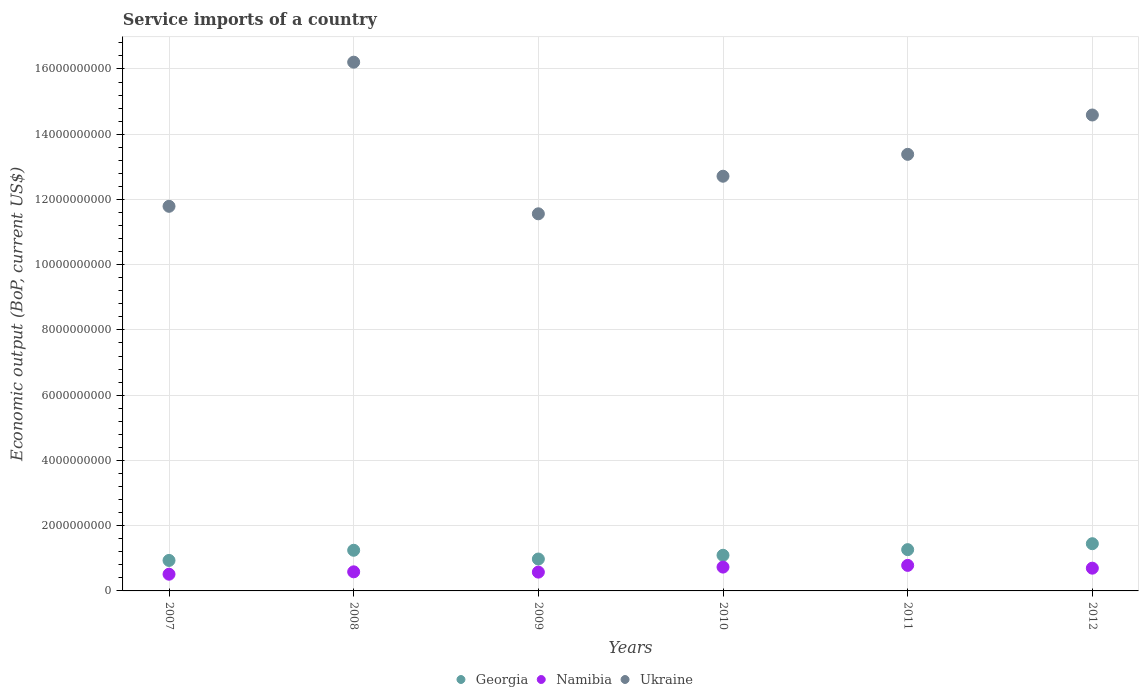How many different coloured dotlines are there?
Provide a short and direct response. 3. What is the service imports in Namibia in 2009?
Give a very brief answer. 5.76e+08. Across all years, what is the maximum service imports in Georgia?
Provide a short and direct response. 1.45e+09. Across all years, what is the minimum service imports in Namibia?
Provide a short and direct response. 5.12e+08. In which year was the service imports in Georgia minimum?
Offer a terse response. 2007. What is the total service imports in Namibia in the graph?
Your answer should be very brief. 3.88e+09. What is the difference between the service imports in Georgia in 2009 and that in 2012?
Offer a very short reply. -4.70e+08. What is the difference between the service imports in Georgia in 2009 and the service imports in Ukraine in 2012?
Provide a short and direct response. -1.36e+1. What is the average service imports in Georgia per year?
Ensure brevity in your answer.  1.16e+09. In the year 2012, what is the difference between the service imports in Ukraine and service imports in Namibia?
Ensure brevity in your answer.  1.39e+1. In how many years, is the service imports in Namibia greater than 7600000000 US$?
Provide a short and direct response. 0. What is the ratio of the service imports in Ukraine in 2007 to that in 2012?
Offer a very short reply. 0.81. What is the difference between the highest and the second highest service imports in Ukraine?
Your answer should be compact. 1.62e+09. What is the difference between the highest and the lowest service imports in Namibia?
Keep it short and to the point. 2.71e+08. How many dotlines are there?
Give a very brief answer. 3. How many years are there in the graph?
Your answer should be very brief. 6. What is the difference between two consecutive major ticks on the Y-axis?
Keep it short and to the point. 2.00e+09. Are the values on the major ticks of Y-axis written in scientific E-notation?
Offer a terse response. No. Does the graph contain any zero values?
Keep it short and to the point. No. What is the title of the graph?
Provide a short and direct response. Service imports of a country. What is the label or title of the Y-axis?
Offer a terse response. Economic output (BoP, current US$). What is the Economic output (BoP, current US$) of Georgia in 2007?
Your response must be concise. 9.35e+08. What is the Economic output (BoP, current US$) in Namibia in 2007?
Your answer should be very brief. 5.12e+08. What is the Economic output (BoP, current US$) of Ukraine in 2007?
Offer a very short reply. 1.18e+1. What is the Economic output (BoP, current US$) of Georgia in 2008?
Provide a succinct answer. 1.25e+09. What is the Economic output (BoP, current US$) in Namibia in 2008?
Your answer should be compact. 5.85e+08. What is the Economic output (BoP, current US$) in Ukraine in 2008?
Offer a terse response. 1.62e+1. What is the Economic output (BoP, current US$) of Georgia in 2009?
Give a very brief answer. 9.78e+08. What is the Economic output (BoP, current US$) of Namibia in 2009?
Ensure brevity in your answer.  5.76e+08. What is the Economic output (BoP, current US$) in Ukraine in 2009?
Give a very brief answer. 1.16e+1. What is the Economic output (BoP, current US$) in Georgia in 2010?
Offer a terse response. 1.09e+09. What is the Economic output (BoP, current US$) in Namibia in 2010?
Your answer should be very brief. 7.31e+08. What is the Economic output (BoP, current US$) of Ukraine in 2010?
Offer a very short reply. 1.27e+1. What is the Economic output (BoP, current US$) of Georgia in 2011?
Make the answer very short. 1.27e+09. What is the Economic output (BoP, current US$) of Namibia in 2011?
Offer a very short reply. 7.83e+08. What is the Economic output (BoP, current US$) of Ukraine in 2011?
Make the answer very short. 1.34e+1. What is the Economic output (BoP, current US$) in Georgia in 2012?
Your answer should be compact. 1.45e+09. What is the Economic output (BoP, current US$) in Namibia in 2012?
Offer a terse response. 6.97e+08. What is the Economic output (BoP, current US$) in Ukraine in 2012?
Your response must be concise. 1.46e+1. Across all years, what is the maximum Economic output (BoP, current US$) of Georgia?
Provide a short and direct response. 1.45e+09. Across all years, what is the maximum Economic output (BoP, current US$) in Namibia?
Ensure brevity in your answer.  7.83e+08. Across all years, what is the maximum Economic output (BoP, current US$) of Ukraine?
Your response must be concise. 1.62e+1. Across all years, what is the minimum Economic output (BoP, current US$) of Georgia?
Provide a succinct answer. 9.35e+08. Across all years, what is the minimum Economic output (BoP, current US$) in Namibia?
Your response must be concise. 5.12e+08. Across all years, what is the minimum Economic output (BoP, current US$) of Ukraine?
Make the answer very short. 1.16e+1. What is the total Economic output (BoP, current US$) of Georgia in the graph?
Keep it short and to the point. 6.96e+09. What is the total Economic output (BoP, current US$) of Namibia in the graph?
Provide a succinct answer. 3.88e+09. What is the total Economic output (BoP, current US$) of Ukraine in the graph?
Your answer should be very brief. 8.02e+1. What is the difference between the Economic output (BoP, current US$) in Georgia in 2007 and that in 2008?
Keep it short and to the point. -3.11e+08. What is the difference between the Economic output (BoP, current US$) in Namibia in 2007 and that in 2008?
Your answer should be very brief. -7.30e+07. What is the difference between the Economic output (BoP, current US$) of Ukraine in 2007 and that in 2008?
Provide a short and direct response. -4.42e+09. What is the difference between the Economic output (BoP, current US$) in Georgia in 2007 and that in 2009?
Your response must be concise. -4.29e+07. What is the difference between the Economic output (BoP, current US$) of Namibia in 2007 and that in 2009?
Make the answer very short. -6.41e+07. What is the difference between the Economic output (BoP, current US$) in Ukraine in 2007 and that in 2009?
Give a very brief answer. 2.30e+08. What is the difference between the Economic output (BoP, current US$) in Georgia in 2007 and that in 2010?
Your answer should be compact. -1.58e+08. What is the difference between the Economic output (BoP, current US$) of Namibia in 2007 and that in 2010?
Ensure brevity in your answer.  -2.18e+08. What is the difference between the Economic output (BoP, current US$) of Ukraine in 2007 and that in 2010?
Provide a short and direct response. -9.22e+08. What is the difference between the Economic output (BoP, current US$) of Georgia in 2007 and that in 2011?
Keep it short and to the point. -3.31e+08. What is the difference between the Economic output (BoP, current US$) in Namibia in 2007 and that in 2011?
Your answer should be very brief. -2.71e+08. What is the difference between the Economic output (BoP, current US$) in Ukraine in 2007 and that in 2011?
Your answer should be compact. -1.59e+09. What is the difference between the Economic output (BoP, current US$) of Georgia in 2007 and that in 2012?
Keep it short and to the point. -5.13e+08. What is the difference between the Economic output (BoP, current US$) of Namibia in 2007 and that in 2012?
Provide a short and direct response. -1.85e+08. What is the difference between the Economic output (BoP, current US$) in Ukraine in 2007 and that in 2012?
Ensure brevity in your answer.  -2.80e+09. What is the difference between the Economic output (BoP, current US$) of Georgia in 2008 and that in 2009?
Provide a succinct answer. 2.69e+08. What is the difference between the Economic output (BoP, current US$) in Namibia in 2008 and that in 2009?
Provide a succinct answer. 8.86e+06. What is the difference between the Economic output (BoP, current US$) in Ukraine in 2008 and that in 2009?
Give a very brief answer. 4.65e+09. What is the difference between the Economic output (BoP, current US$) of Georgia in 2008 and that in 2010?
Your answer should be very brief. 1.54e+08. What is the difference between the Economic output (BoP, current US$) of Namibia in 2008 and that in 2010?
Provide a succinct answer. -1.45e+08. What is the difference between the Economic output (BoP, current US$) of Ukraine in 2008 and that in 2010?
Ensure brevity in your answer.  3.50e+09. What is the difference between the Economic output (BoP, current US$) of Georgia in 2008 and that in 2011?
Your response must be concise. -1.90e+07. What is the difference between the Economic output (BoP, current US$) in Namibia in 2008 and that in 2011?
Ensure brevity in your answer.  -1.98e+08. What is the difference between the Economic output (BoP, current US$) of Ukraine in 2008 and that in 2011?
Your response must be concise. 2.82e+09. What is the difference between the Economic output (BoP, current US$) in Georgia in 2008 and that in 2012?
Offer a terse response. -2.01e+08. What is the difference between the Economic output (BoP, current US$) in Namibia in 2008 and that in 2012?
Give a very brief answer. -1.12e+08. What is the difference between the Economic output (BoP, current US$) of Ukraine in 2008 and that in 2012?
Offer a very short reply. 1.62e+09. What is the difference between the Economic output (BoP, current US$) in Georgia in 2009 and that in 2010?
Give a very brief answer. -1.15e+08. What is the difference between the Economic output (BoP, current US$) of Namibia in 2009 and that in 2010?
Provide a short and direct response. -1.54e+08. What is the difference between the Economic output (BoP, current US$) of Ukraine in 2009 and that in 2010?
Give a very brief answer. -1.15e+09. What is the difference between the Economic output (BoP, current US$) in Georgia in 2009 and that in 2011?
Keep it short and to the point. -2.88e+08. What is the difference between the Economic output (BoP, current US$) in Namibia in 2009 and that in 2011?
Give a very brief answer. -2.06e+08. What is the difference between the Economic output (BoP, current US$) in Ukraine in 2009 and that in 2011?
Offer a terse response. -1.82e+09. What is the difference between the Economic output (BoP, current US$) of Georgia in 2009 and that in 2012?
Keep it short and to the point. -4.70e+08. What is the difference between the Economic output (BoP, current US$) in Namibia in 2009 and that in 2012?
Offer a very short reply. -1.21e+08. What is the difference between the Economic output (BoP, current US$) in Ukraine in 2009 and that in 2012?
Offer a very short reply. -3.03e+09. What is the difference between the Economic output (BoP, current US$) of Georgia in 2010 and that in 2011?
Ensure brevity in your answer.  -1.73e+08. What is the difference between the Economic output (BoP, current US$) of Namibia in 2010 and that in 2011?
Keep it short and to the point. -5.22e+07. What is the difference between the Economic output (BoP, current US$) in Ukraine in 2010 and that in 2011?
Provide a succinct answer. -6.71e+08. What is the difference between the Economic output (BoP, current US$) in Georgia in 2010 and that in 2012?
Make the answer very short. -3.55e+08. What is the difference between the Economic output (BoP, current US$) of Namibia in 2010 and that in 2012?
Your answer should be compact. 3.34e+07. What is the difference between the Economic output (BoP, current US$) of Ukraine in 2010 and that in 2012?
Provide a short and direct response. -1.88e+09. What is the difference between the Economic output (BoP, current US$) in Georgia in 2011 and that in 2012?
Give a very brief answer. -1.82e+08. What is the difference between the Economic output (BoP, current US$) in Namibia in 2011 and that in 2012?
Your answer should be very brief. 8.56e+07. What is the difference between the Economic output (BoP, current US$) of Ukraine in 2011 and that in 2012?
Your answer should be very brief. -1.21e+09. What is the difference between the Economic output (BoP, current US$) in Georgia in 2007 and the Economic output (BoP, current US$) in Namibia in 2008?
Offer a very short reply. 3.49e+08. What is the difference between the Economic output (BoP, current US$) of Georgia in 2007 and the Economic output (BoP, current US$) of Ukraine in 2008?
Make the answer very short. -1.53e+1. What is the difference between the Economic output (BoP, current US$) in Namibia in 2007 and the Economic output (BoP, current US$) in Ukraine in 2008?
Provide a short and direct response. -1.57e+1. What is the difference between the Economic output (BoP, current US$) of Georgia in 2007 and the Economic output (BoP, current US$) of Namibia in 2009?
Your answer should be compact. 3.58e+08. What is the difference between the Economic output (BoP, current US$) in Georgia in 2007 and the Economic output (BoP, current US$) in Ukraine in 2009?
Provide a succinct answer. -1.06e+1. What is the difference between the Economic output (BoP, current US$) in Namibia in 2007 and the Economic output (BoP, current US$) in Ukraine in 2009?
Keep it short and to the point. -1.10e+1. What is the difference between the Economic output (BoP, current US$) in Georgia in 2007 and the Economic output (BoP, current US$) in Namibia in 2010?
Ensure brevity in your answer.  2.04e+08. What is the difference between the Economic output (BoP, current US$) in Georgia in 2007 and the Economic output (BoP, current US$) in Ukraine in 2010?
Give a very brief answer. -1.18e+1. What is the difference between the Economic output (BoP, current US$) of Namibia in 2007 and the Economic output (BoP, current US$) of Ukraine in 2010?
Your answer should be very brief. -1.22e+1. What is the difference between the Economic output (BoP, current US$) of Georgia in 2007 and the Economic output (BoP, current US$) of Namibia in 2011?
Your answer should be very brief. 1.52e+08. What is the difference between the Economic output (BoP, current US$) of Georgia in 2007 and the Economic output (BoP, current US$) of Ukraine in 2011?
Provide a succinct answer. -1.24e+1. What is the difference between the Economic output (BoP, current US$) in Namibia in 2007 and the Economic output (BoP, current US$) in Ukraine in 2011?
Provide a succinct answer. -1.29e+1. What is the difference between the Economic output (BoP, current US$) in Georgia in 2007 and the Economic output (BoP, current US$) in Namibia in 2012?
Provide a short and direct response. 2.37e+08. What is the difference between the Economic output (BoP, current US$) of Georgia in 2007 and the Economic output (BoP, current US$) of Ukraine in 2012?
Ensure brevity in your answer.  -1.37e+1. What is the difference between the Economic output (BoP, current US$) in Namibia in 2007 and the Economic output (BoP, current US$) in Ukraine in 2012?
Your response must be concise. -1.41e+1. What is the difference between the Economic output (BoP, current US$) of Georgia in 2008 and the Economic output (BoP, current US$) of Namibia in 2009?
Provide a succinct answer. 6.70e+08. What is the difference between the Economic output (BoP, current US$) in Georgia in 2008 and the Economic output (BoP, current US$) in Ukraine in 2009?
Offer a terse response. -1.03e+1. What is the difference between the Economic output (BoP, current US$) in Namibia in 2008 and the Economic output (BoP, current US$) in Ukraine in 2009?
Your answer should be very brief. -1.10e+1. What is the difference between the Economic output (BoP, current US$) of Georgia in 2008 and the Economic output (BoP, current US$) of Namibia in 2010?
Your answer should be very brief. 5.16e+08. What is the difference between the Economic output (BoP, current US$) of Georgia in 2008 and the Economic output (BoP, current US$) of Ukraine in 2010?
Your answer should be compact. -1.15e+1. What is the difference between the Economic output (BoP, current US$) of Namibia in 2008 and the Economic output (BoP, current US$) of Ukraine in 2010?
Ensure brevity in your answer.  -1.21e+1. What is the difference between the Economic output (BoP, current US$) of Georgia in 2008 and the Economic output (BoP, current US$) of Namibia in 2011?
Give a very brief answer. 4.63e+08. What is the difference between the Economic output (BoP, current US$) in Georgia in 2008 and the Economic output (BoP, current US$) in Ukraine in 2011?
Make the answer very short. -1.21e+1. What is the difference between the Economic output (BoP, current US$) in Namibia in 2008 and the Economic output (BoP, current US$) in Ukraine in 2011?
Provide a succinct answer. -1.28e+1. What is the difference between the Economic output (BoP, current US$) of Georgia in 2008 and the Economic output (BoP, current US$) of Namibia in 2012?
Your response must be concise. 5.49e+08. What is the difference between the Economic output (BoP, current US$) of Georgia in 2008 and the Economic output (BoP, current US$) of Ukraine in 2012?
Provide a short and direct response. -1.33e+1. What is the difference between the Economic output (BoP, current US$) in Namibia in 2008 and the Economic output (BoP, current US$) in Ukraine in 2012?
Offer a very short reply. -1.40e+1. What is the difference between the Economic output (BoP, current US$) in Georgia in 2009 and the Economic output (BoP, current US$) in Namibia in 2010?
Your response must be concise. 2.47e+08. What is the difference between the Economic output (BoP, current US$) of Georgia in 2009 and the Economic output (BoP, current US$) of Ukraine in 2010?
Keep it short and to the point. -1.17e+1. What is the difference between the Economic output (BoP, current US$) in Namibia in 2009 and the Economic output (BoP, current US$) in Ukraine in 2010?
Offer a terse response. -1.21e+1. What is the difference between the Economic output (BoP, current US$) of Georgia in 2009 and the Economic output (BoP, current US$) of Namibia in 2011?
Your answer should be very brief. 1.95e+08. What is the difference between the Economic output (BoP, current US$) of Georgia in 2009 and the Economic output (BoP, current US$) of Ukraine in 2011?
Give a very brief answer. -1.24e+1. What is the difference between the Economic output (BoP, current US$) of Namibia in 2009 and the Economic output (BoP, current US$) of Ukraine in 2011?
Ensure brevity in your answer.  -1.28e+1. What is the difference between the Economic output (BoP, current US$) in Georgia in 2009 and the Economic output (BoP, current US$) in Namibia in 2012?
Your answer should be compact. 2.80e+08. What is the difference between the Economic output (BoP, current US$) of Georgia in 2009 and the Economic output (BoP, current US$) of Ukraine in 2012?
Offer a terse response. -1.36e+1. What is the difference between the Economic output (BoP, current US$) of Namibia in 2009 and the Economic output (BoP, current US$) of Ukraine in 2012?
Offer a very short reply. -1.40e+1. What is the difference between the Economic output (BoP, current US$) of Georgia in 2010 and the Economic output (BoP, current US$) of Namibia in 2011?
Ensure brevity in your answer.  3.10e+08. What is the difference between the Economic output (BoP, current US$) in Georgia in 2010 and the Economic output (BoP, current US$) in Ukraine in 2011?
Offer a very short reply. -1.23e+1. What is the difference between the Economic output (BoP, current US$) in Namibia in 2010 and the Economic output (BoP, current US$) in Ukraine in 2011?
Keep it short and to the point. -1.27e+1. What is the difference between the Economic output (BoP, current US$) in Georgia in 2010 and the Economic output (BoP, current US$) in Namibia in 2012?
Give a very brief answer. 3.95e+08. What is the difference between the Economic output (BoP, current US$) of Georgia in 2010 and the Economic output (BoP, current US$) of Ukraine in 2012?
Make the answer very short. -1.35e+1. What is the difference between the Economic output (BoP, current US$) of Namibia in 2010 and the Economic output (BoP, current US$) of Ukraine in 2012?
Ensure brevity in your answer.  -1.39e+1. What is the difference between the Economic output (BoP, current US$) in Georgia in 2011 and the Economic output (BoP, current US$) in Namibia in 2012?
Your response must be concise. 5.68e+08. What is the difference between the Economic output (BoP, current US$) in Georgia in 2011 and the Economic output (BoP, current US$) in Ukraine in 2012?
Provide a short and direct response. -1.33e+1. What is the difference between the Economic output (BoP, current US$) of Namibia in 2011 and the Economic output (BoP, current US$) of Ukraine in 2012?
Offer a terse response. -1.38e+1. What is the average Economic output (BoP, current US$) in Georgia per year?
Keep it short and to the point. 1.16e+09. What is the average Economic output (BoP, current US$) in Namibia per year?
Your answer should be very brief. 6.47e+08. What is the average Economic output (BoP, current US$) of Ukraine per year?
Your answer should be compact. 1.34e+1. In the year 2007, what is the difference between the Economic output (BoP, current US$) of Georgia and Economic output (BoP, current US$) of Namibia?
Your answer should be very brief. 4.22e+08. In the year 2007, what is the difference between the Economic output (BoP, current US$) in Georgia and Economic output (BoP, current US$) in Ukraine?
Offer a very short reply. -1.09e+1. In the year 2007, what is the difference between the Economic output (BoP, current US$) of Namibia and Economic output (BoP, current US$) of Ukraine?
Offer a terse response. -1.13e+1. In the year 2008, what is the difference between the Economic output (BoP, current US$) of Georgia and Economic output (BoP, current US$) of Namibia?
Provide a succinct answer. 6.61e+08. In the year 2008, what is the difference between the Economic output (BoP, current US$) in Georgia and Economic output (BoP, current US$) in Ukraine?
Ensure brevity in your answer.  -1.50e+1. In the year 2008, what is the difference between the Economic output (BoP, current US$) of Namibia and Economic output (BoP, current US$) of Ukraine?
Your response must be concise. -1.56e+1. In the year 2009, what is the difference between the Economic output (BoP, current US$) of Georgia and Economic output (BoP, current US$) of Namibia?
Make the answer very short. 4.01e+08. In the year 2009, what is the difference between the Economic output (BoP, current US$) in Georgia and Economic output (BoP, current US$) in Ukraine?
Provide a short and direct response. -1.06e+1. In the year 2009, what is the difference between the Economic output (BoP, current US$) of Namibia and Economic output (BoP, current US$) of Ukraine?
Provide a short and direct response. -1.10e+1. In the year 2010, what is the difference between the Economic output (BoP, current US$) of Georgia and Economic output (BoP, current US$) of Namibia?
Your answer should be compact. 3.62e+08. In the year 2010, what is the difference between the Economic output (BoP, current US$) of Georgia and Economic output (BoP, current US$) of Ukraine?
Provide a succinct answer. -1.16e+1. In the year 2010, what is the difference between the Economic output (BoP, current US$) of Namibia and Economic output (BoP, current US$) of Ukraine?
Give a very brief answer. -1.20e+1. In the year 2011, what is the difference between the Economic output (BoP, current US$) in Georgia and Economic output (BoP, current US$) in Namibia?
Ensure brevity in your answer.  4.82e+08. In the year 2011, what is the difference between the Economic output (BoP, current US$) in Georgia and Economic output (BoP, current US$) in Ukraine?
Keep it short and to the point. -1.21e+1. In the year 2011, what is the difference between the Economic output (BoP, current US$) of Namibia and Economic output (BoP, current US$) of Ukraine?
Make the answer very short. -1.26e+1. In the year 2012, what is the difference between the Economic output (BoP, current US$) of Georgia and Economic output (BoP, current US$) of Namibia?
Make the answer very short. 7.50e+08. In the year 2012, what is the difference between the Economic output (BoP, current US$) in Georgia and Economic output (BoP, current US$) in Ukraine?
Keep it short and to the point. -1.31e+1. In the year 2012, what is the difference between the Economic output (BoP, current US$) in Namibia and Economic output (BoP, current US$) in Ukraine?
Offer a very short reply. -1.39e+1. What is the ratio of the Economic output (BoP, current US$) of Georgia in 2007 to that in 2008?
Provide a short and direct response. 0.75. What is the ratio of the Economic output (BoP, current US$) of Namibia in 2007 to that in 2008?
Provide a short and direct response. 0.88. What is the ratio of the Economic output (BoP, current US$) of Ukraine in 2007 to that in 2008?
Give a very brief answer. 0.73. What is the ratio of the Economic output (BoP, current US$) in Georgia in 2007 to that in 2009?
Your answer should be very brief. 0.96. What is the ratio of the Economic output (BoP, current US$) in Namibia in 2007 to that in 2009?
Make the answer very short. 0.89. What is the ratio of the Economic output (BoP, current US$) of Ukraine in 2007 to that in 2009?
Ensure brevity in your answer.  1.02. What is the ratio of the Economic output (BoP, current US$) in Georgia in 2007 to that in 2010?
Offer a terse response. 0.86. What is the ratio of the Economic output (BoP, current US$) of Namibia in 2007 to that in 2010?
Ensure brevity in your answer.  0.7. What is the ratio of the Economic output (BoP, current US$) in Ukraine in 2007 to that in 2010?
Ensure brevity in your answer.  0.93. What is the ratio of the Economic output (BoP, current US$) of Georgia in 2007 to that in 2011?
Provide a succinct answer. 0.74. What is the ratio of the Economic output (BoP, current US$) of Namibia in 2007 to that in 2011?
Keep it short and to the point. 0.65. What is the ratio of the Economic output (BoP, current US$) in Ukraine in 2007 to that in 2011?
Your response must be concise. 0.88. What is the ratio of the Economic output (BoP, current US$) in Georgia in 2007 to that in 2012?
Your answer should be compact. 0.65. What is the ratio of the Economic output (BoP, current US$) of Namibia in 2007 to that in 2012?
Your response must be concise. 0.73. What is the ratio of the Economic output (BoP, current US$) in Ukraine in 2007 to that in 2012?
Offer a very short reply. 0.81. What is the ratio of the Economic output (BoP, current US$) of Georgia in 2008 to that in 2009?
Keep it short and to the point. 1.27. What is the ratio of the Economic output (BoP, current US$) in Namibia in 2008 to that in 2009?
Your response must be concise. 1.02. What is the ratio of the Economic output (BoP, current US$) in Ukraine in 2008 to that in 2009?
Your answer should be very brief. 1.4. What is the ratio of the Economic output (BoP, current US$) in Georgia in 2008 to that in 2010?
Make the answer very short. 1.14. What is the ratio of the Economic output (BoP, current US$) in Namibia in 2008 to that in 2010?
Your response must be concise. 0.8. What is the ratio of the Economic output (BoP, current US$) in Ukraine in 2008 to that in 2010?
Your response must be concise. 1.27. What is the ratio of the Economic output (BoP, current US$) of Georgia in 2008 to that in 2011?
Give a very brief answer. 0.98. What is the ratio of the Economic output (BoP, current US$) of Namibia in 2008 to that in 2011?
Provide a short and direct response. 0.75. What is the ratio of the Economic output (BoP, current US$) of Ukraine in 2008 to that in 2011?
Offer a very short reply. 1.21. What is the ratio of the Economic output (BoP, current US$) of Georgia in 2008 to that in 2012?
Your answer should be very brief. 0.86. What is the ratio of the Economic output (BoP, current US$) of Namibia in 2008 to that in 2012?
Your answer should be very brief. 0.84. What is the ratio of the Economic output (BoP, current US$) of Ukraine in 2008 to that in 2012?
Your answer should be very brief. 1.11. What is the ratio of the Economic output (BoP, current US$) of Georgia in 2009 to that in 2010?
Make the answer very short. 0.89. What is the ratio of the Economic output (BoP, current US$) in Namibia in 2009 to that in 2010?
Your answer should be very brief. 0.79. What is the ratio of the Economic output (BoP, current US$) in Ukraine in 2009 to that in 2010?
Keep it short and to the point. 0.91. What is the ratio of the Economic output (BoP, current US$) of Georgia in 2009 to that in 2011?
Your answer should be very brief. 0.77. What is the ratio of the Economic output (BoP, current US$) in Namibia in 2009 to that in 2011?
Offer a very short reply. 0.74. What is the ratio of the Economic output (BoP, current US$) in Ukraine in 2009 to that in 2011?
Keep it short and to the point. 0.86. What is the ratio of the Economic output (BoP, current US$) in Georgia in 2009 to that in 2012?
Provide a short and direct response. 0.68. What is the ratio of the Economic output (BoP, current US$) in Namibia in 2009 to that in 2012?
Keep it short and to the point. 0.83. What is the ratio of the Economic output (BoP, current US$) of Ukraine in 2009 to that in 2012?
Your response must be concise. 0.79. What is the ratio of the Economic output (BoP, current US$) of Georgia in 2010 to that in 2011?
Give a very brief answer. 0.86. What is the ratio of the Economic output (BoP, current US$) in Namibia in 2010 to that in 2011?
Ensure brevity in your answer.  0.93. What is the ratio of the Economic output (BoP, current US$) of Ukraine in 2010 to that in 2011?
Ensure brevity in your answer.  0.95. What is the ratio of the Economic output (BoP, current US$) of Georgia in 2010 to that in 2012?
Offer a terse response. 0.75. What is the ratio of the Economic output (BoP, current US$) in Namibia in 2010 to that in 2012?
Your response must be concise. 1.05. What is the ratio of the Economic output (BoP, current US$) in Ukraine in 2010 to that in 2012?
Ensure brevity in your answer.  0.87. What is the ratio of the Economic output (BoP, current US$) in Georgia in 2011 to that in 2012?
Offer a terse response. 0.87. What is the ratio of the Economic output (BoP, current US$) in Namibia in 2011 to that in 2012?
Your response must be concise. 1.12. What is the ratio of the Economic output (BoP, current US$) of Ukraine in 2011 to that in 2012?
Make the answer very short. 0.92. What is the difference between the highest and the second highest Economic output (BoP, current US$) in Georgia?
Your response must be concise. 1.82e+08. What is the difference between the highest and the second highest Economic output (BoP, current US$) in Namibia?
Your answer should be very brief. 5.22e+07. What is the difference between the highest and the second highest Economic output (BoP, current US$) in Ukraine?
Your answer should be compact. 1.62e+09. What is the difference between the highest and the lowest Economic output (BoP, current US$) of Georgia?
Offer a very short reply. 5.13e+08. What is the difference between the highest and the lowest Economic output (BoP, current US$) in Namibia?
Your answer should be very brief. 2.71e+08. What is the difference between the highest and the lowest Economic output (BoP, current US$) of Ukraine?
Provide a succinct answer. 4.65e+09. 